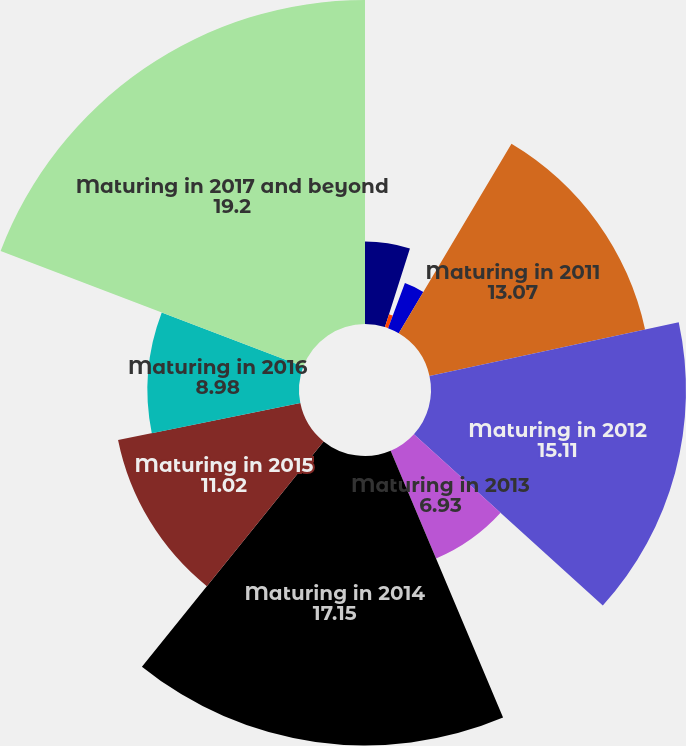Convert chart. <chart><loc_0><loc_0><loc_500><loc_500><pie_chart><fcel>Maturing in 2008<fcel>Maturing in 2009<fcel>Maturing in 2010<fcel>Maturing in 2011<fcel>Maturing in 2012<fcel>Maturing in 2013<fcel>Maturing in 2014<fcel>Maturing in 2015<fcel>Maturing in 2016<fcel>Maturing in 2017 and beyond<nl><fcel>4.89%<fcel>0.8%<fcel>2.85%<fcel>13.07%<fcel>15.11%<fcel>6.93%<fcel>17.15%<fcel>11.02%<fcel>8.98%<fcel>19.2%<nl></chart> 